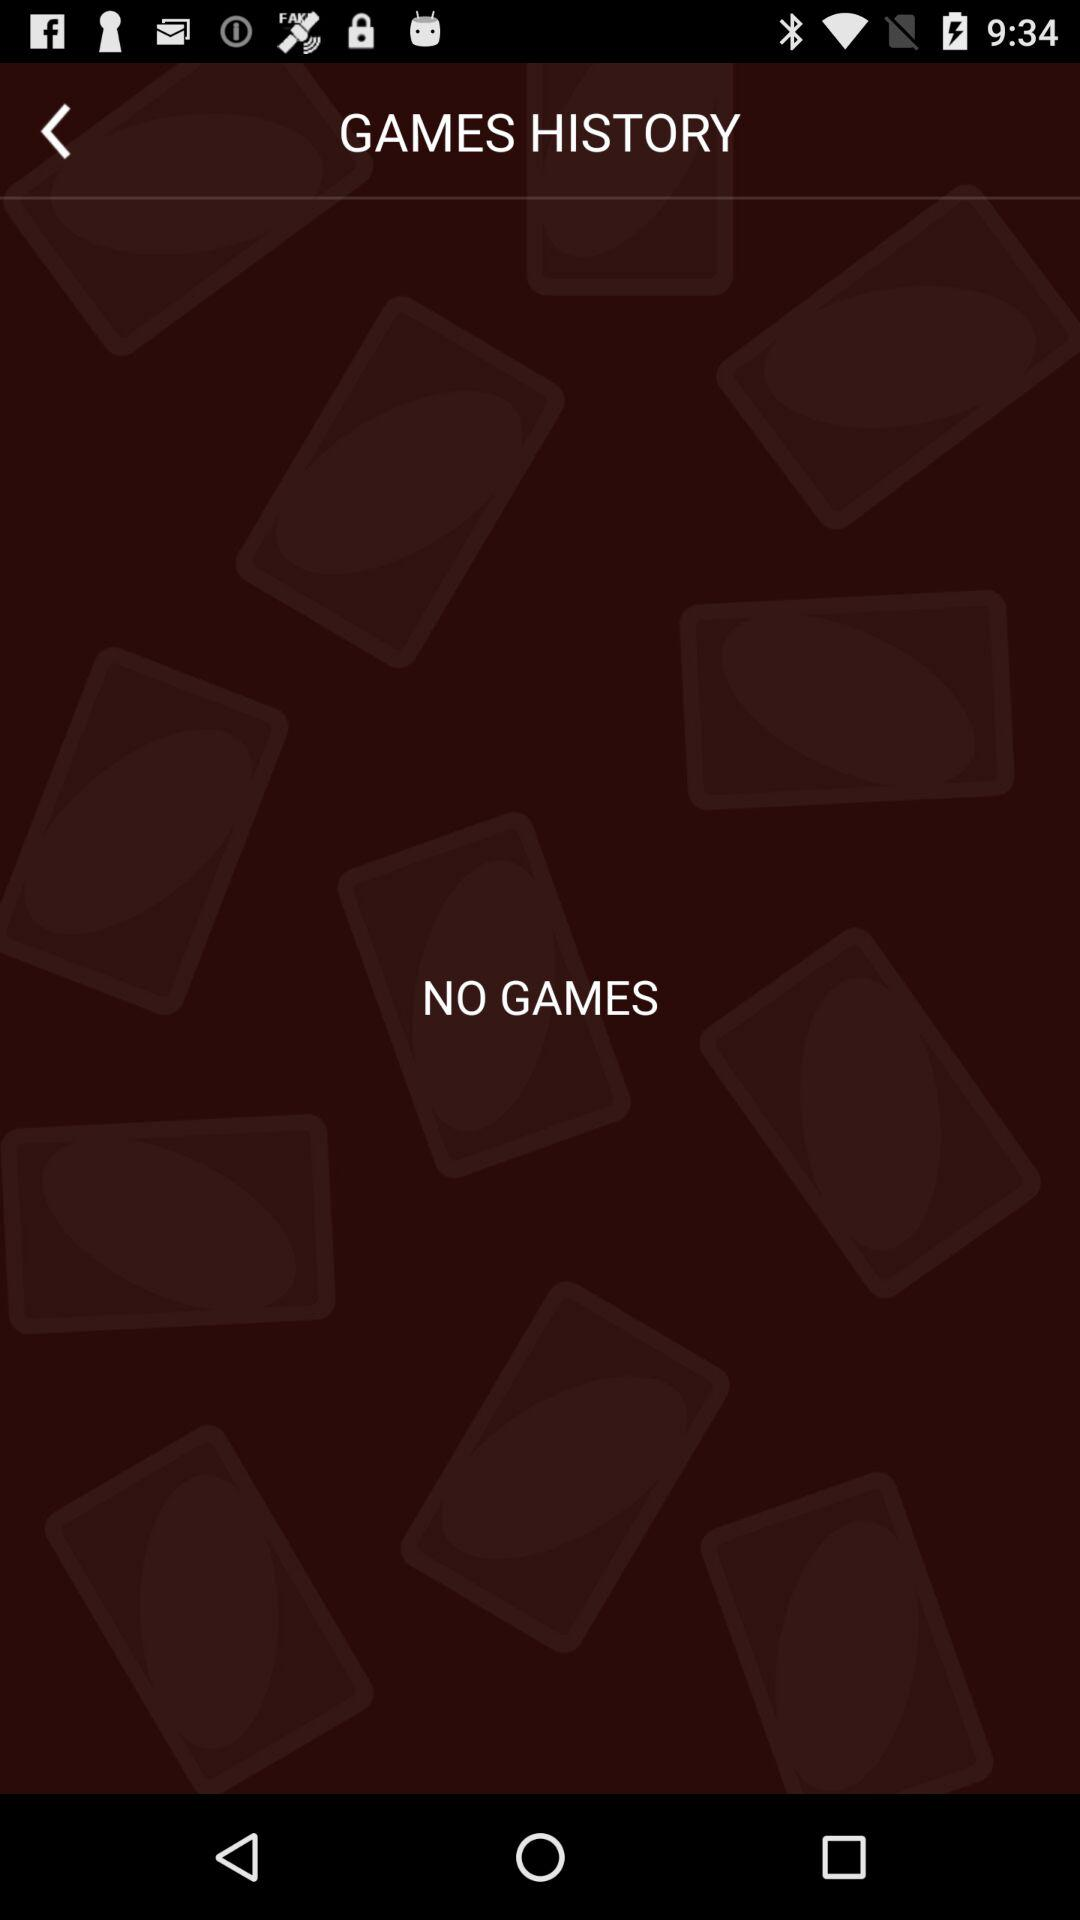Are there any games? There are no games. 